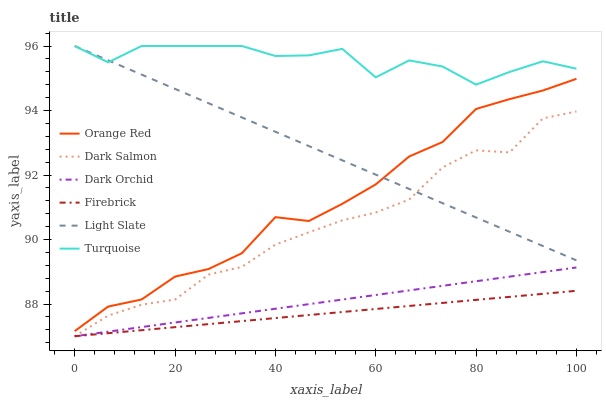Does Firebrick have the minimum area under the curve?
Answer yes or no. Yes. Does Turquoise have the maximum area under the curve?
Answer yes or no. Yes. Does Light Slate have the minimum area under the curve?
Answer yes or no. No. Does Light Slate have the maximum area under the curve?
Answer yes or no. No. Is Firebrick the smoothest?
Answer yes or no. Yes. Is Turquoise the roughest?
Answer yes or no. Yes. Is Light Slate the smoothest?
Answer yes or no. No. Is Light Slate the roughest?
Answer yes or no. No. Does Firebrick have the lowest value?
Answer yes or no. Yes. Does Light Slate have the lowest value?
Answer yes or no. No. Does Light Slate have the highest value?
Answer yes or no. Yes. Does Firebrick have the highest value?
Answer yes or no. No. Is Dark Orchid less than Turquoise?
Answer yes or no. Yes. Is Light Slate greater than Dark Orchid?
Answer yes or no. Yes. Does Light Slate intersect Orange Red?
Answer yes or no. Yes. Is Light Slate less than Orange Red?
Answer yes or no. No. Is Light Slate greater than Orange Red?
Answer yes or no. No. Does Dark Orchid intersect Turquoise?
Answer yes or no. No. 